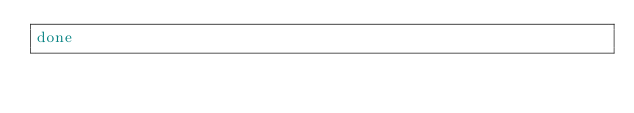Convert code to text. <code><loc_0><loc_0><loc_500><loc_500><_Bash_>done
</code> 